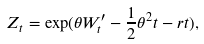<formula> <loc_0><loc_0><loc_500><loc_500>Z _ { t } = \exp ( \theta W ^ { \prime } _ { t } - \frac { 1 } { 2 } \theta ^ { 2 } t - r t ) ,</formula> 